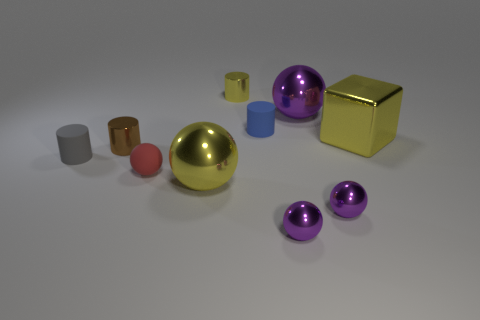What size is the cylinder on the right side of the yellow cylinder? The cylinder on the right side of the yellow cylinder appears to be medium-sized in relation to the other objects in the image, particularly smaller than the yellow cylinder but larger than the smallest purple sphere. 